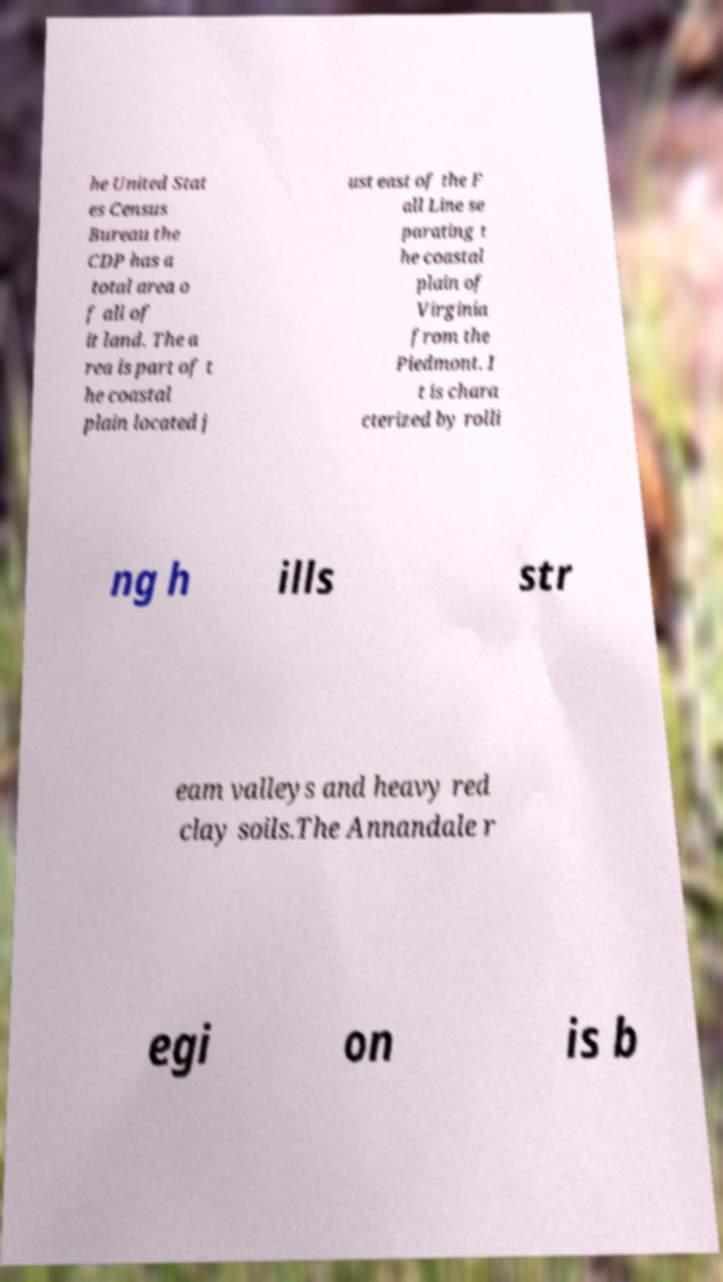Please read and relay the text visible in this image. What does it say? he United Stat es Census Bureau the CDP has a total area o f all of it land. The a rea is part of t he coastal plain located j ust east of the F all Line se parating t he coastal plain of Virginia from the Piedmont. I t is chara cterized by rolli ng h ills str eam valleys and heavy red clay soils.The Annandale r egi on is b 